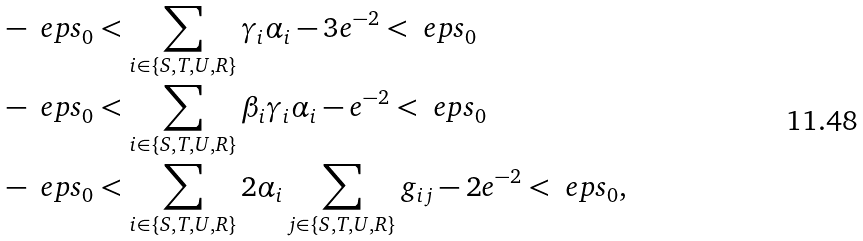Convert formula to latex. <formula><loc_0><loc_0><loc_500><loc_500>& - \ e p s _ { 0 } < \sum _ { i \in \{ S , T , U , R \} } \gamma _ { i } \alpha _ { i } - 3 e ^ { - 2 } < \ e p s _ { 0 } \\ & - \ e p s _ { 0 } < \sum _ { i \in \{ S , T , U , R \} } \beta _ { i } \gamma _ { i } \alpha _ { i } - e ^ { - 2 } < \ e p s _ { 0 } \\ & - \ e p s _ { 0 } < \sum _ { i \in \{ S , T , U , R \} } 2 \alpha _ { i } \sum _ { j \in \{ S , T , U , R \} } g _ { i j } - 2 e ^ { - 2 } < \ e p s _ { 0 } ,</formula> 